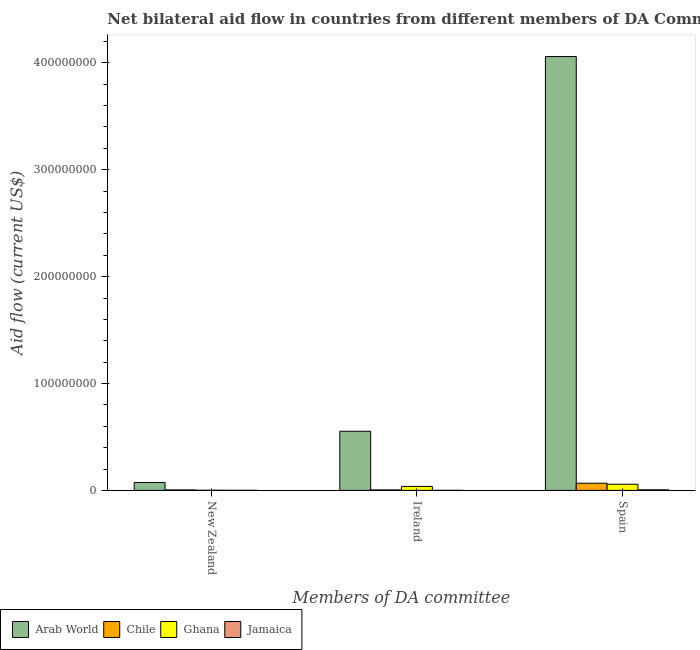How many different coloured bars are there?
Provide a succinct answer. 4. How many groups of bars are there?
Provide a short and direct response. 3. Are the number of bars on each tick of the X-axis equal?
Your answer should be compact. Yes. How many bars are there on the 2nd tick from the left?
Make the answer very short. 4. What is the amount of aid provided by new zealand in Chile?
Provide a short and direct response. 4.60e+05. Across all countries, what is the maximum amount of aid provided by spain?
Keep it short and to the point. 4.06e+08. Across all countries, what is the minimum amount of aid provided by new zealand?
Ensure brevity in your answer.  6.00e+04. In which country was the amount of aid provided by spain maximum?
Your response must be concise. Arab World. In which country was the amount of aid provided by spain minimum?
Make the answer very short. Jamaica. What is the total amount of aid provided by spain in the graph?
Your response must be concise. 4.19e+08. What is the difference between the amount of aid provided by new zealand in Ghana and that in Arab World?
Your answer should be compact. -7.27e+06. What is the difference between the amount of aid provided by spain in Jamaica and the amount of aid provided by new zealand in Chile?
Make the answer very short. 6.00e+04. What is the average amount of aid provided by spain per country?
Your answer should be compact. 1.05e+08. What is the difference between the amount of aid provided by ireland and amount of aid provided by new zealand in Chile?
Your response must be concise. -3.00e+04. What is the ratio of the amount of aid provided by ireland in Ghana to that in Jamaica?
Ensure brevity in your answer.  93.5. What is the difference between the highest and the second highest amount of aid provided by spain?
Your response must be concise. 3.99e+08. What is the difference between the highest and the lowest amount of aid provided by new zealand?
Make the answer very short. 7.33e+06. In how many countries, is the amount of aid provided by ireland greater than the average amount of aid provided by ireland taken over all countries?
Offer a terse response. 1. What does the 2nd bar from the left in Ireland represents?
Offer a very short reply. Chile. What does the 4th bar from the right in New Zealand represents?
Your response must be concise. Arab World. How many bars are there?
Ensure brevity in your answer.  12. What is the difference between two consecutive major ticks on the Y-axis?
Keep it short and to the point. 1.00e+08. Are the values on the major ticks of Y-axis written in scientific E-notation?
Give a very brief answer. No. Does the graph contain any zero values?
Offer a very short reply. No. Does the graph contain grids?
Provide a short and direct response. No. Where does the legend appear in the graph?
Your response must be concise. Bottom left. How many legend labels are there?
Provide a succinct answer. 4. What is the title of the graph?
Provide a short and direct response. Net bilateral aid flow in countries from different members of DA Committee. Does "Tajikistan" appear as one of the legend labels in the graph?
Provide a succinct answer. No. What is the label or title of the X-axis?
Your response must be concise. Members of DA committee. What is the label or title of the Y-axis?
Ensure brevity in your answer.  Aid flow (current US$). What is the Aid flow (current US$) in Arab World in New Zealand?
Your answer should be compact. 7.39e+06. What is the Aid flow (current US$) of Arab World in Ireland?
Make the answer very short. 5.53e+07. What is the Aid flow (current US$) of Chile in Ireland?
Offer a terse response. 4.30e+05. What is the Aid flow (current US$) of Ghana in Ireland?
Offer a terse response. 3.74e+06. What is the Aid flow (current US$) in Jamaica in Ireland?
Provide a short and direct response. 4.00e+04. What is the Aid flow (current US$) in Arab World in Spain?
Your answer should be compact. 4.06e+08. What is the Aid flow (current US$) in Chile in Spain?
Keep it short and to the point. 6.70e+06. What is the Aid flow (current US$) of Ghana in Spain?
Your answer should be compact. 5.77e+06. What is the Aid flow (current US$) of Jamaica in Spain?
Keep it short and to the point. 5.20e+05. Across all Members of DA committee, what is the maximum Aid flow (current US$) in Arab World?
Give a very brief answer. 4.06e+08. Across all Members of DA committee, what is the maximum Aid flow (current US$) in Chile?
Your response must be concise. 6.70e+06. Across all Members of DA committee, what is the maximum Aid flow (current US$) in Ghana?
Provide a succinct answer. 5.77e+06. Across all Members of DA committee, what is the maximum Aid flow (current US$) in Jamaica?
Give a very brief answer. 5.20e+05. Across all Members of DA committee, what is the minimum Aid flow (current US$) in Arab World?
Your answer should be compact. 7.39e+06. Across all Members of DA committee, what is the minimum Aid flow (current US$) in Chile?
Your answer should be very brief. 4.30e+05. Across all Members of DA committee, what is the minimum Aid flow (current US$) of Jamaica?
Offer a very short reply. 4.00e+04. What is the total Aid flow (current US$) of Arab World in the graph?
Your answer should be compact. 4.69e+08. What is the total Aid flow (current US$) of Chile in the graph?
Give a very brief answer. 7.59e+06. What is the total Aid flow (current US$) in Ghana in the graph?
Give a very brief answer. 9.63e+06. What is the total Aid flow (current US$) in Jamaica in the graph?
Provide a short and direct response. 6.20e+05. What is the difference between the Aid flow (current US$) in Arab World in New Zealand and that in Ireland?
Ensure brevity in your answer.  -4.79e+07. What is the difference between the Aid flow (current US$) of Ghana in New Zealand and that in Ireland?
Your response must be concise. -3.62e+06. What is the difference between the Aid flow (current US$) of Arab World in New Zealand and that in Spain?
Provide a succinct answer. -3.98e+08. What is the difference between the Aid flow (current US$) of Chile in New Zealand and that in Spain?
Provide a succinct answer. -6.24e+06. What is the difference between the Aid flow (current US$) of Ghana in New Zealand and that in Spain?
Your response must be concise. -5.65e+06. What is the difference between the Aid flow (current US$) in Jamaica in New Zealand and that in Spain?
Make the answer very short. -4.60e+05. What is the difference between the Aid flow (current US$) in Arab World in Ireland and that in Spain?
Ensure brevity in your answer.  -3.51e+08. What is the difference between the Aid flow (current US$) of Chile in Ireland and that in Spain?
Offer a terse response. -6.27e+06. What is the difference between the Aid flow (current US$) of Ghana in Ireland and that in Spain?
Ensure brevity in your answer.  -2.03e+06. What is the difference between the Aid flow (current US$) of Jamaica in Ireland and that in Spain?
Ensure brevity in your answer.  -4.80e+05. What is the difference between the Aid flow (current US$) in Arab World in New Zealand and the Aid flow (current US$) in Chile in Ireland?
Offer a very short reply. 6.96e+06. What is the difference between the Aid flow (current US$) in Arab World in New Zealand and the Aid flow (current US$) in Ghana in Ireland?
Offer a terse response. 3.65e+06. What is the difference between the Aid flow (current US$) of Arab World in New Zealand and the Aid flow (current US$) of Jamaica in Ireland?
Make the answer very short. 7.35e+06. What is the difference between the Aid flow (current US$) in Chile in New Zealand and the Aid flow (current US$) in Ghana in Ireland?
Ensure brevity in your answer.  -3.28e+06. What is the difference between the Aid flow (current US$) in Arab World in New Zealand and the Aid flow (current US$) in Chile in Spain?
Offer a terse response. 6.90e+05. What is the difference between the Aid flow (current US$) in Arab World in New Zealand and the Aid flow (current US$) in Ghana in Spain?
Make the answer very short. 1.62e+06. What is the difference between the Aid flow (current US$) of Arab World in New Zealand and the Aid flow (current US$) of Jamaica in Spain?
Make the answer very short. 6.87e+06. What is the difference between the Aid flow (current US$) of Chile in New Zealand and the Aid flow (current US$) of Ghana in Spain?
Provide a succinct answer. -5.31e+06. What is the difference between the Aid flow (current US$) of Ghana in New Zealand and the Aid flow (current US$) of Jamaica in Spain?
Give a very brief answer. -4.00e+05. What is the difference between the Aid flow (current US$) in Arab World in Ireland and the Aid flow (current US$) in Chile in Spain?
Your answer should be compact. 4.86e+07. What is the difference between the Aid flow (current US$) in Arab World in Ireland and the Aid flow (current US$) in Ghana in Spain?
Keep it short and to the point. 4.96e+07. What is the difference between the Aid flow (current US$) of Arab World in Ireland and the Aid flow (current US$) of Jamaica in Spain?
Your answer should be very brief. 5.48e+07. What is the difference between the Aid flow (current US$) in Chile in Ireland and the Aid flow (current US$) in Ghana in Spain?
Give a very brief answer. -5.34e+06. What is the difference between the Aid flow (current US$) of Ghana in Ireland and the Aid flow (current US$) of Jamaica in Spain?
Provide a short and direct response. 3.22e+06. What is the average Aid flow (current US$) in Arab World per Members of DA committee?
Offer a terse response. 1.56e+08. What is the average Aid flow (current US$) of Chile per Members of DA committee?
Offer a terse response. 2.53e+06. What is the average Aid flow (current US$) in Ghana per Members of DA committee?
Give a very brief answer. 3.21e+06. What is the average Aid flow (current US$) in Jamaica per Members of DA committee?
Provide a succinct answer. 2.07e+05. What is the difference between the Aid flow (current US$) in Arab World and Aid flow (current US$) in Chile in New Zealand?
Provide a short and direct response. 6.93e+06. What is the difference between the Aid flow (current US$) in Arab World and Aid flow (current US$) in Ghana in New Zealand?
Make the answer very short. 7.27e+06. What is the difference between the Aid flow (current US$) in Arab World and Aid flow (current US$) in Jamaica in New Zealand?
Your answer should be very brief. 7.33e+06. What is the difference between the Aid flow (current US$) of Arab World and Aid flow (current US$) of Chile in Ireland?
Offer a very short reply. 5.49e+07. What is the difference between the Aid flow (current US$) in Arab World and Aid flow (current US$) in Ghana in Ireland?
Your answer should be very brief. 5.16e+07. What is the difference between the Aid flow (current US$) in Arab World and Aid flow (current US$) in Jamaica in Ireland?
Your response must be concise. 5.53e+07. What is the difference between the Aid flow (current US$) in Chile and Aid flow (current US$) in Ghana in Ireland?
Provide a succinct answer. -3.31e+06. What is the difference between the Aid flow (current US$) in Ghana and Aid flow (current US$) in Jamaica in Ireland?
Provide a short and direct response. 3.70e+06. What is the difference between the Aid flow (current US$) of Arab World and Aid flow (current US$) of Chile in Spain?
Keep it short and to the point. 3.99e+08. What is the difference between the Aid flow (current US$) in Arab World and Aid flow (current US$) in Ghana in Spain?
Provide a succinct answer. 4.00e+08. What is the difference between the Aid flow (current US$) of Arab World and Aid flow (current US$) of Jamaica in Spain?
Give a very brief answer. 4.05e+08. What is the difference between the Aid flow (current US$) of Chile and Aid flow (current US$) of Ghana in Spain?
Offer a very short reply. 9.30e+05. What is the difference between the Aid flow (current US$) in Chile and Aid flow (current US$) in Jamaica in Spain?
Provide a succinct answer. 6.18e+06. What is the difference between the Aid flow (current US$) in Ghana and Aid flow (current US$) in Jamaica in Spain?
Ensure brevity in your answer.  5.25e+06. What is the ratio of the Aid flow (current US$) in Arab World in New Zealand to that in Ireland?
Ensure brevity in your answer.  0.13. What is the ratio of the Aid flow (current US$) of Chile in New Zealand to that in Ireland?
Give a very brief answer. 1.07. What is the ratio of the Aid flow (current US$) in Ghana in New Zealand to that in Ireland?
Make the answer very short. 0.03. What is the ratio of the Aid flow (current US$) of Arab World in New Zealand to that in Spain?
Offer a very short reply. 0.02. What is the ratio of the Aid flow (current US$) of Chile in New Zealand to that in Spain?
Make the answer very short. 0.07. What is the ratio of the Aid flow (current US$) of Ghana in New Zealand to that in Spain?
Give a very brief answer. 0.02. What is the ratio of the Aid flow (current US$) in Jamaica in New Zealand to that in Spain?
Ensure brevity in your answer.  0.12. What is the ratio of the Aid flow (current US$) in Arab World in Ireland to that in Spain?
Ensure brevity in your answer.  0.14. What is the ratio of the Aid flow (current US$) of Chile in Ireland to that in Spain?
Your response must be concise. 0.06. What is the ratio of the Aid flow (current US$) of Ghana in Ireland to that in Spain?
Provide a succinct answer. 0.65. What is the ratio of the Aid flow (current US$) in Jamaica in Ireland to that in Spain?
Give a very brief answer. 0.08. What is the difference between the highest and the second highest Aid flow (current US$) of Arab World?
Give a very brief answer. 3.51e+08. What is the difference between the highest and the second highest Aid flow (current US$) of Chile?
Your answer should be very brief. 6.24e+06. What is the difference between the highest and the second highest Aid flow (current US$) of Ghana?
Give a very brief answer. 2.03e+06. What is the difference between the highest and the lowest Aid flow (current US$) of Arab World?
Give a very brief answer. 3.98e+08. What is the difference between the highest and the lowest Aid flow (current US$) of Chile?
Your answer should be compact. 6.27e+06. What is the difference between the highest and the lowest Aid flow (current US$) of Ghana?
Your answer should be compact. 5.65e+06. What is the difference between the highest and the lowest Aid flow (current US$) of Jamaica?
Make the answer very short. 4.80e+05. 